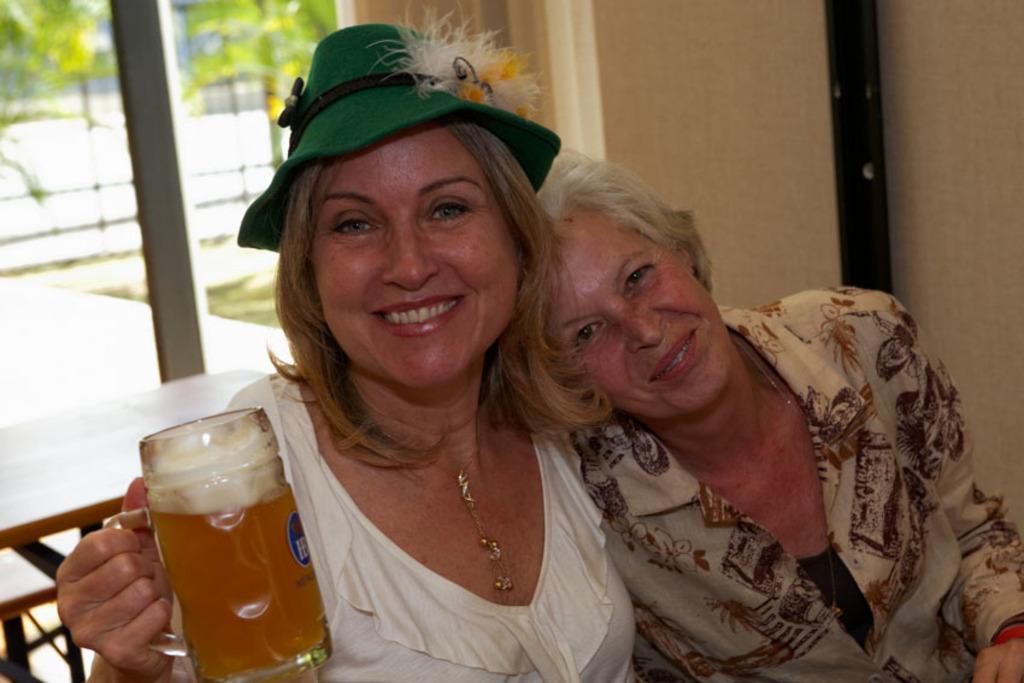Describe this image in one or two sentences. In this image i can see there are two women who are smiling. The women on the left side is holding a cup and wearing a green hat. 